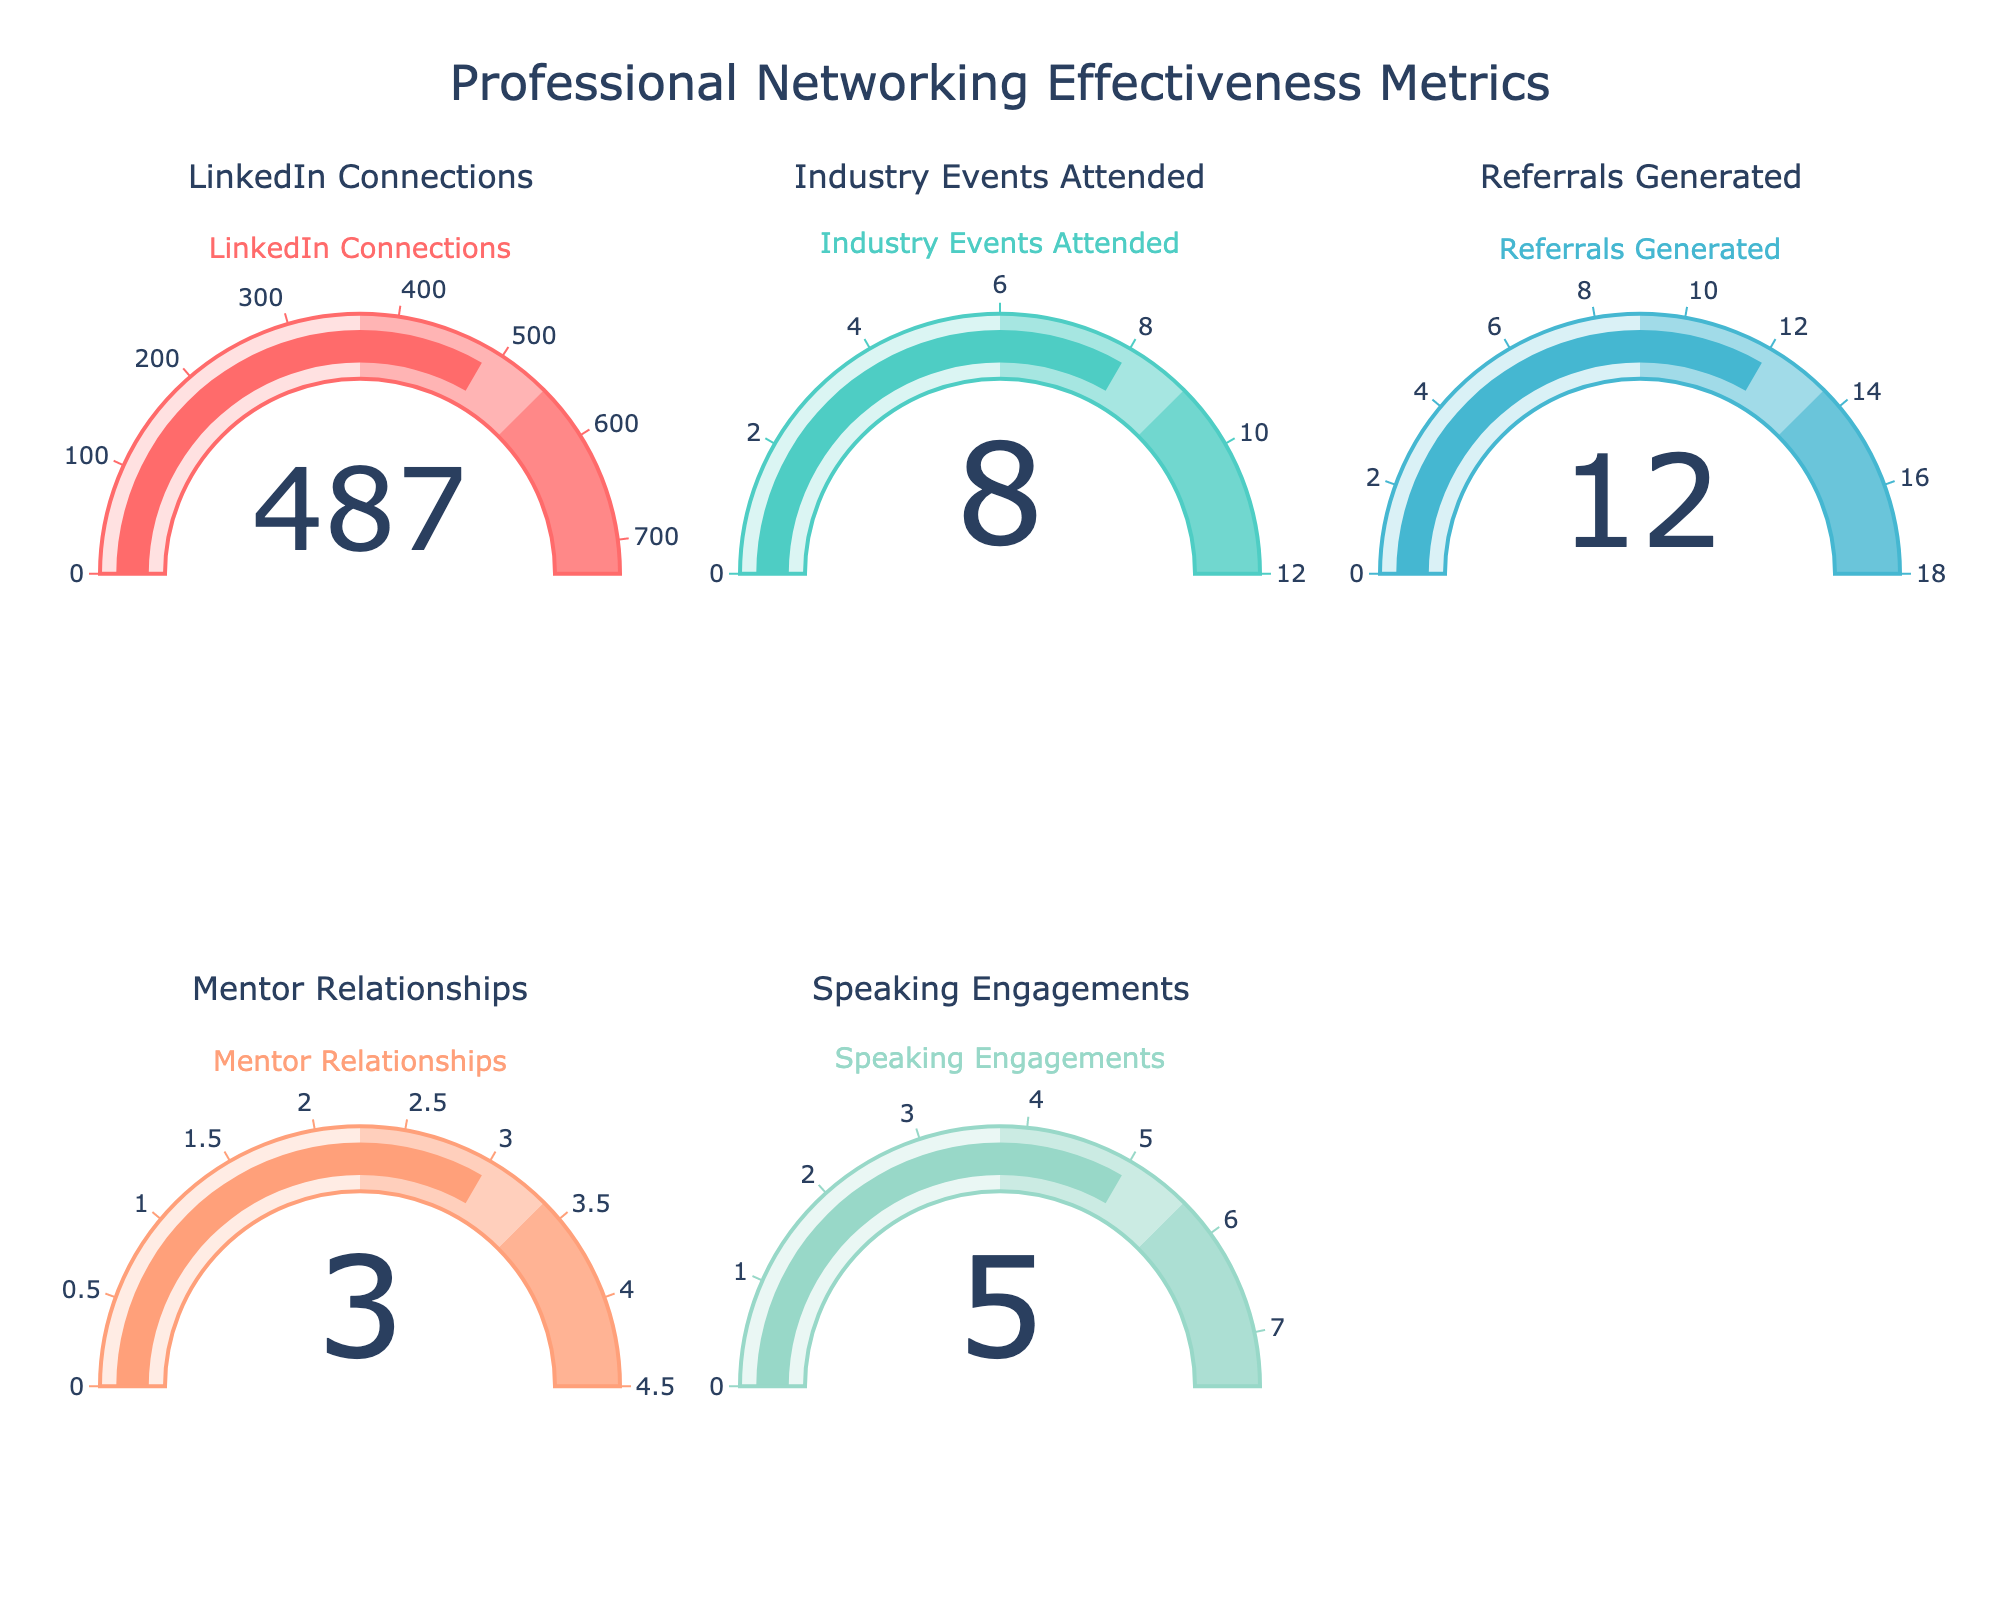How many LinkedIn connections are shown on the gauge chart? The value for "LinkedIn Connections" is indicated on its respective gauge, which reads 487.
Answer: 487 What is the sum of the values for Industry Events Attended and Speaking Engagements? The "Industry Events Attended" gauge shows a value of 8, and the "Speaking Engagements" gauge shows a value of 5. Summing these values gives 8 + 5 = 13.
Answer: 13 Which metric has the lowest value on their gauge chart? Comparing all the values on the gauges, "Mentor Relationships" has the lowest value, which is 3.
Answer: Mentor Relationships What's the average value of all metrics displayed on the gauge charts? Adding all the metrics: 487 (LinkedIn Connections), 8 (Industry Events Attended), 12 (Referrals Generated), 3 (Mentor Relationships), 5 (Speaking Engagements), we get a total of 515. Dividing by the number of metrics, which is 5, gives an average of 515/5 = 103.
Answer: 103 Are there more Referrals Generated or Speaking Engagements according to the gauges? The "Referrals Generated" gauge shows a value of 12, whereas "Speaking Engagements" shows a value of 5. Since 12 is greater than 5, there are more Referrals Generated.
Answer: Referrals Generated Which metric uses the color '#FF6B6B' in its gauge chart? The gauge for "LinkedIn Connections" utilizes the color '#FF6B6B', as per the custom color palette defined.
Answer: LinkedIn Connections If you were to double the number of Industry Events Attended, how would the new value compare to the number of Referrals Generated? Doubling the industry events: 8 * 2 = 16. The new value (16) is greater than the Referrals Generated, which is 12.
Answer: Greater than How many metrics displayed have a value less than 10 according to the gauges? According to the gauge values, three metrics have values less than 10: "Industry Events Attended" (8), "Mentor Relationships" (3), and "Speaking Engagements" (5).
Answer: 3 What is the median value of the metrics displayed? Ordering the values from smallest to largest: 3 (Mentor Relationships), 5 (Speaking Engagements), 8 (Industry Events Attended), 12 (Referrals Generated), 487 (LinkedIn Connections). The median is the middle number, which is 8.
Answer: 8 